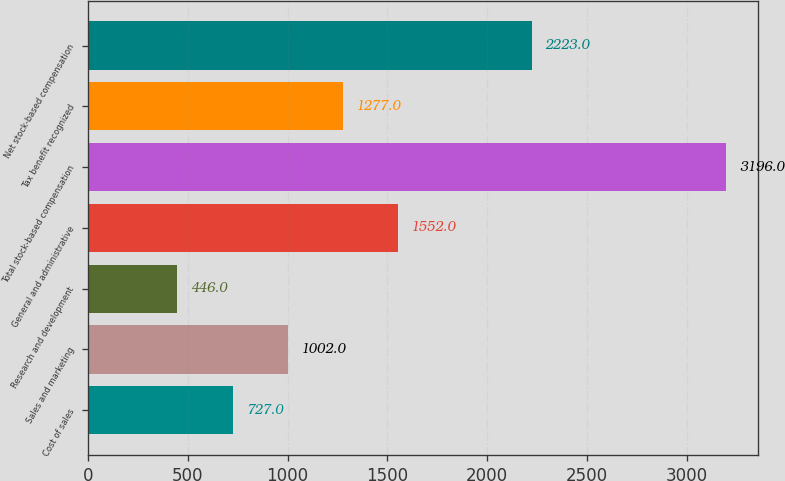Convert chart. <chart><loc_0><loc_0><loc_500><loc_500><bar_chart><fcel>Cost of sales<fcel>Sales and marketing<fcel>Research and development<fcel>General and administrative<fcel>Total stock-based compensation<fcel>Tax benefit recognized<fcel>Net stock-based compensation<nl><fcel>727<fcel>1002<fcel>446<fcel>1552<fcel>3196<fcel>1277<fcel>2223<nl></chart> 